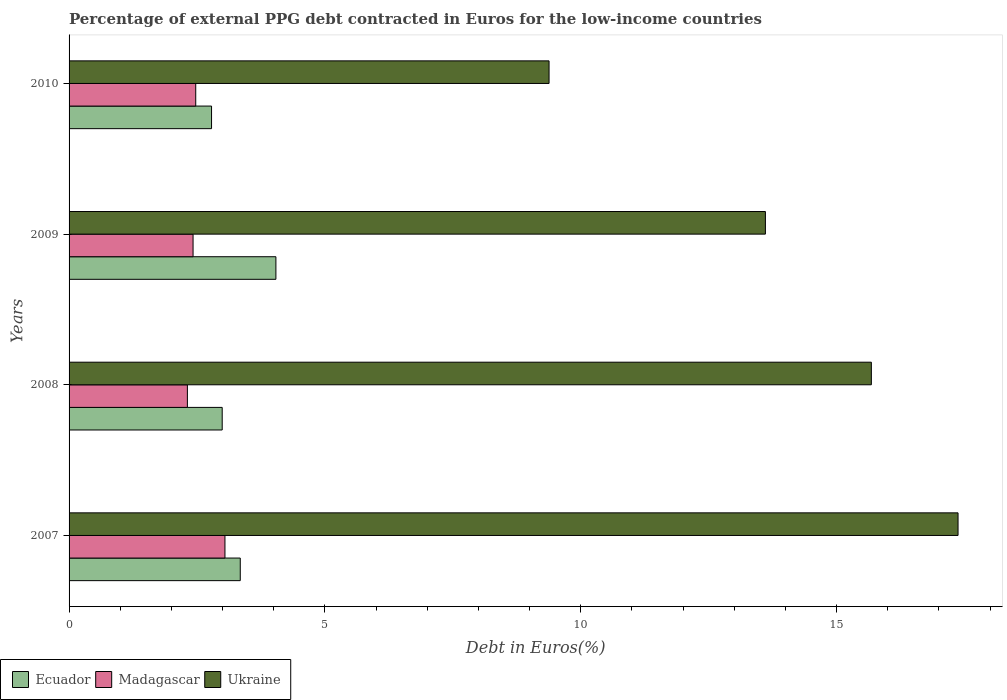Are the number of bars per tick equal to the number of legend labels?
Your answer should be very brief. Yes. How many bars are there on the 4th tick from the top?
Make the answer very short. 3. In how many cases, is the number of bars for a given year not equal to the number of legend labels?
Your response must be concise. 0. What is the percentage of external PPG debt contracted in Euros in Madagascar in 2009?
Offer a very short reply. 2.42. Across all years, what is the maximum percentage of external PPG debt contracted in Euros in Madagascar?
Make the answer very short. 3.05. Across all years, what is the minimum percentage of external PPG debt contracted in Euros in Madagascar?
Ensure brevity in your answer.  2.31. What is the total percentage of external PPG debt contracted in Euros in Ecuador in the graph?
Ensure brevity in your answer.  13.17. What is the difference between the percentage of external PPG debt contracted in Euros in Ukraine in 2008 and that in 2009?
Ensure brevity in your answer.  2.07. What is the difference between the percentage of external PPG debt contracted in Euros in Ecuador in 2010 and the percentage of external PPG debt contracted in Euros in Ukraine in 2007?
Your answer should be very brief. -14.59. What is the average percentage of external PPG debt contracted in Euros in Ukraine per year?
Your answer should be very brief. 14.01. In the year 2008, what is the difference between the percentage of external PPG debt contracted in Euros in Madagascar and percentage of external PPG debt contracted in Euros in Ukraine?
Offer a terse response. -13.37. In how many years, is the percentage of external PPG debt contracted in Euros in Madagascar greater than 1 %?
Your answer should be very brief. 4. What is the ratio of the percentage of external PPG debt contracted in Euros in Ukraine in 2007 to that in 2008?
Your answer should be compact. 1.11. Is the percentage of external PPG debt contracted in Euros in Ukraine in 2007 less than that in 2010?
Ensure brevity in your answer.  No. What is the difference between the highest and the second highest percentage of external PPG debt contracted in Euros in Madagascar?
Your answer should be compact. 0.57. What is the difference between the highest and the lowest percentage of external PPG debt contracted in Euros in Ecuador?
Provide a succinct answer. 1.26. In how many years, is the percentage of external PPG debt contracted in Euros in Madagascar greater than the average percentage of external PPG debt contracted in Euros in Madagascar taken over all years?
Make the answer very short. 1. Is the sum of the percentage of external PPG debt contracted in Euros in Ukraine in 2007 and 2010 greater than the maximum percentage of external PPG debt contracted in Euros in Madagascar across all years?
Ensure brevity in your answer.  Yes. What does the 3rd bar from the top in 2010 represents?
Offer a terse response. Ecuador. What does the 2nd bar from the bottom in 2008 represents?
Provide a succinct answer. Madagascar. Are all the bars in the graph horizontal?
Keep it short and to the point. Yes. What is the difference between two consecutive major ticks on the X-axis?
Provide a succinct answer. 5. Does the graph contain grids?
Your answer should be very brief. No. How many legend labels are there?
Provide a short and direct response. 3. How are the legend labels stacked?
Provide a succinct answer. Horizontal. What is the title of the graph?
Provide a short and direct response. Percentage of external PPG debt contracted in Euros for the low-income countries. Does "Tunisia" appear as one of the legend labels in the graph?
Give a very brief answer. No. What is the label or title of the X-axis?
Offer a terse response. Debt in Euros(%). What is the Debt in Euros(%) of Ecuador in 2007?
Your answer should be compact. 3.35. What is the Debt in Euros(%) of Madagascar in 2007?
Provide a succinct answer. 3.05. What is the Debt in Euros(%) of Ukraine in 2007?
Provide a succinct answer. 17.38. What is the Debt in Euros(%) of Ecuador in 2008?
Provide a short and direct response. 2.99. What is the Debt in Euros(%) in Madagascar in 2008?
Your response must be concise. 2.31. What is the Debt in Euros(%) in Ukraine in 2008?
Ensure brevity in your answer.  15.68. What is the Debt in Euros(%) in Ecuador in 2009?
Keep it short and to the point. 4.04. What is the Debt in Euros(%) in Madagascar in 2009?
Offer a terse response. 2.42. What is the Debt in Euros(%) in Ukraine in 2009?
Ensure brevity in your answer.  13.61. What is the Debt in Euros(%) of Ecuador in 2010?
Provide a succinct answer. 2.78. What is the Debt in Euros(%) in Madagascar in 2010?
Offer a very short reply. 2.48. What is the Debt in Euros(%) of Ukraine in 2010?
Your answer should be compact. 9.38. Across all years, what is the maximum Debt in Euros(%) in Ecuador?
Provide a succinct answer. 4.04. Across all years, what is the maximum Debt in Euros(%) in Madagascar?
Offer a very short reply. 3.05. Across all years, what is the maximum Debt in Euros(%) in Ukraine?
Offer a very short reply. 17.38. Across all years, what is the minimum Debt in Euros(%) of Ecuador?
Your answer should be very brief. 2.78. Across all years, what is the minimum Debt in Euros(%) of Madagascar?
Your response must be concise. 2.31. Across all years, what is the minimum Debt in Euros(%) in Ukraine?
Ensure brevity in your answer.  9.38. What is the total Debt in Euros(%) in Ecuador in the graph?
Your answer should be compact. 13.17. What is the total Debt in Euros(%) in Madagascar in the graph?
Your response must be concise. 10.26. What is the total Debt in Euros(%) in Ukraine in the graph?
Give a very brief answer. 56.05. What is the difference between the Debt in Euros(%) of Ecuador in 2007 and that in 2008?
Ensure brevity in your answer.  0.35. What is the difference between the Debt in Euros(%) of Madagascar in 2007 and that in 2008?
Your answer should be compact. 0.73. What is the difference between the Debt in Euros(%) of Ukraine in 2007 and that in 2008?
Offer a terse response. 1.69. What is the difference between the Debt in Euros(%) of Ecuador in 2007 and that in 2009?
Your answer should be very brief. -0.7. What is the difference between the Debt in Euros(%) in Madagascar in 2007 and that in 2009?
Keep it short and to the point. 0.62. What is the difference between the Debt in Euros(%) in Ukraine in 2007 and that in 2009?
Make the answer very short. 3.77. What is the difference between the Debt in Euros(%) in Ecuador in 2007 and that in 2010?
Your answer should be very brief. 0.56. What is the difference between the Debt in Euros(%) in Madagascar in 2007 and that in 2010?
Ensure brevity in your answer.  0.57. What is the difference between the Debt in Euros(%) of Ukraine in 2007 and that in 2010?
Provide a short and direct response. 7.99. What is the difference between the Debt in Euros(%) in Ecuador in 2008 and that in 2009?
Your answer should be very brief. -1.05. What is the difference between the Debt in Euros(%) of Madagascar in 2008 and that in 2009?
Provide a short and direct response. -0.11. What is the difference between the Debt in Euros(%) of Ukraine in 2008 and that in 2009?
Offer a terse response. 2.07. What is the difference between the Debt in Euros(%) of Ecuador in 2008 and that in 2010?
Keep it short and to the point. 0.21. What is the difference between the Debt in Euros(%) in Madagascar in 2008 and that in 2010?
Your answer should be compact. -0.16. What is the difference between the Debt in Euros(%) in Ukraine in 2008 and that in 2010?
Ensure brevity in your answer.  6.3. What is the difference between the Debt in Euros(%) in Ecuador in 2009 and that in 2010?
Offer a terse response. 1.26. What is the difference between the Debt in Euros(%) in Madagascar in 2009 and that in 2010?
Your answer should be compact. -0.05. What is the difference between the Debt in Euros(%) in Ukraine in 2009 and that in 2010?
Make the answer very short. 4.23. What is the difference between the Debt in Euros(%) in Ecuador in 2007 and the Debt in Euros(%) in Madagascar in 2008?
Offer a terse response. 1.03. What is the difference between the Debt in Euros(%) of Ecuador in 2007 and the Debt in Euros(%) of Ukraine in 2008?
Your response must be concise. -12.33. What is the difference between the Debt in Euros(%) of Madagascar in 2007 and the Debt in Euros(%) of Ukraine in 2008?
Offer a very short reply. -12.63. What is the difference between the Debt in Euros(%) in Ecuador in 2007 and the Debt in Euros(%) in Madagascar in 2009?
Your answer should be compact. 0.92. What is the difference between the Debt in Euros(%) in Ecuador in 2007 and the Debt in Euros(%) in Ukraine in 2009?
Ensure brevity in your answer.  -10.26. What is the difference between the Debt in Euros(%) of Madagascar in 2007 and the Debt in Euros(%) of Ukraine in 2009?
Offer a terse response. -10.56. What is the difference between the Debt in Euros(%) in Ecuador in 2007 and the Debt in Euros(%) in Madagascar in 2010?
Your answer should be very brief. 0.87. What is the difference between the Debt in Euros(%) in Ecuador in 2007 and the Debt in Euros(%) in Ukraine in 2010?
Your answer should be compact. -6.04. What is the difference between the Debt in Euros(%) of Madagascar in 2007 and the Debt in Euros(%) of Ukraine in 2010?
Your answer should be compact. -6.33. What is the difference between the Debt in Euros(%) of Ecuador in 2008 and the Debt in Euros(%) of Madagascar in 2009?
Ensure brevity in your answer.  0.57. What is the difference between the Debt in Euros(%) in Ecuador in 2008 and the Debt in Euros(%) in Ukraine in 2009?
Offer a terse response. -10.62. What is the difference between the Debt in Euros(%) in Madagascar in 2008 and the Debt in Euros(%) in Ukraine in 2009?
Ensure brevity in your answer.  -11.3. What is the difference between the Debt in Euros(%) of Ecuador in 2008 and the Debt in Euros(%) of Madagascar in 2010?
Your response must be concise. 0.52. What is the difference between the Debt in Euros(%) in Ecuador in 2008 and the Debt in Euros(%) in Ukraine in 2010?
Offer a very short reply. -6.39. What is the difference between the Debt in Euros(%) in Madagascar in 2008 and the Debt in Euros(%) in Ukraine in 2010?
Your response must be concise. -7.07. What is the difference between the Debt in Euros(%) of Ecuador in 2009 and the Debt in Euros(%) of Madagascar in 2010?
Your answer should be compact. 1.57. What is the difference between the Debt in Euros(%) of Ecuador in 2009 and the Debt in Euros(%) of Ukraine in 2010?
Your response must be concise. -5.34. What is the difference between the Debt in Euros(%) in Madagascar in 2009 and the Debt in Euros(%) in Ukraine in 2010?
Offer a very short reply. -6.96. What is the average Debt in Euros(%) in Ecuador per year?
Offer a very short reply. 3.29. What is the average Debt in Euros(%) in Madagascar per year?
Provide a succinct answer. 2.56. What is the average Debt in Euros(%) in Ukraine per year?
Provide a succinct answer. 14.01. In the year 2007, what is the difference between the Debt in Euros(%) in Ecuador and Debt in Euros(%) in Madagascar?
Your answer should be compact. 0.3. In the year 2007, what is the difference between the Debt in Euros(%) of Ecuador and Debt in Euros(%) of Ukraine?
Ensure brevity in your answer.  -14.03. In the year 2007, what is the difference between the Debt in Euros(%) in Madagascar and Debt in Euros(%) in Ukraine?
Provide a short and direct response. -14.33. In the year 2008, what is the difference between the Debt in Euros(%) in Ecuador and Debt in Euros(%) in Madagascar?
Provide a succinct answer. 0.68. In the year 2008, what is the difference between the Debt in Euros(%) of Ecuador and Debt in Euros(%) of Ukraine?
Keep it short and to the point. -12.69. In the year 2008, what is the difference between the Debt in Euros(%) of Madagascar and Debt in Euros(%) of Ukraine?
Give a very brief answer. -13.37. In the year 2009, what is the difference between the Debt in Euros(%) of Ecuador and Debt in Euros(%) of Madagascar?
Make the answer very short. 1.62. In the year 2009, what is the difference between the Debt in Euros(%) in Ecuador and Debt in Euros(%) in Ukraine?
Offer a terse response. -9.57. In the year 2009, what is the difference between the Debt in Euros(%) in Madagascar and Debt in Euros(%) in Ukraine?
Your answer should be compact. -11.19. In the year 2010, what is the difference between the Debt in Euros(%) of Ecuador and Debt in Euros(%) of Madagascar?
Your answer should be very brief. 0.31. In the year 2010, what is the difference between the Debt in Euros(%) in Ecuador and Debt in Euros(%) in Ukraine?
Provide a short and direct response. -6.6. In the year 2010, what is the difference between the Debt in Euros(%) in Madagascar and Debt in Euros(%) in Ukraine?
Ensure brevity in your answer.  -6.91. What is the ratio of the Debt in Euros(%) of Ecuador in 2007 to that in 2008?
Offer a terse response. 1.12. What is the ratio of the Debt in Euros(%) of Madagascar in 2007 to that in 2008?
Make the answer very short. 1.32. What is the ratio of the Debt in Euros(%) of Ukraine in 2007 to that in 2008?
Provide a short and direct response. 1.11. What is the ratio of the Debt in Euros(%) of Ecuador in 2007 to that in 2009?
Ensure brevity in your answer.  0.83. What is the ratio of the Debt in Euros(%) in Madagascar in 2007 to that in 2009?
Provide a succinct answer. 1.26. What is the ratio of the Debt in Euros(%) in Ukraine in 2007 to that in 2009?
Give a very brief answer. 1.28. What is the ratio of the Debt in Euros(%) in Ecuador in 2007 to that in 2010?
Give a very brief answer. 1.2. What is the ratio of the Debt in Euros(%) of Madagascar in 2007 to that in 2010?
Your answer should be compact. 1.23. What is the ratio of the Debt in Euros(%) in Ukraine in 2007 to that in 2010?
Provide a short and direct response. 1.85. What is the ratio of the Debt in Euros(%) of Ecuador in 2008 to that in 2009?
Offer a very short reply. 0.74. What is the ratio of the Debt in Euros(%) in Madagascar in 2008 to that in 2009?
Provide a succinct answer. 0.95. What is the ratio of the Debt in Euros(%) in Ukraine in 2008 to that in 2009?
Provide a short and direct response. 1.15. What is the ratio of the Debt in Euros(%) of Ecuador in 2008 to that in 2010?
Give a very brief answer. 1.07. What is the ratio of the Debt in Euros(%) of Madagascar in 2008 to that in 2010?
Provide a short and direct response. 0.93. What is the ratio of the Debt in Euros(%) in Ukraine in 2008 to that in 2010?
Offer a very short reply. 1.67. What is the ratio of the Debt in Euros(%) in Ecuador in 2009 to that in 2010?
Your response must be concise. 1.45. What is the ratio of the Debt in Euros(%) in Madagascar in 2009 to that in 2010?
Offer a very short reply. 0.98. What is the ratio of the Debt in Euros(%) in Ukraine in 2009 to that in 2010?
Offer a very short reply. 1.45. What is the difference between the highest and the second highest Debt in Euros(%) in Ecuador?
Keep it short and to the point. 0.7. What is the difference between the highest and the second highest Debt in Euros(%) of Madagascar?
Provide a succinct answer. 0.57. What is the difference between the highest and the second highest Debt in Euros(%) of Ukraine?
Your answer should be compact. 1.69. What is the difference between the highest and the lowest Debt in Euros(%) of Ecuador?
Ensure brevity in your answer.  1.26. What is the difference between the highest and the lowest Debt in Euros(%) of Madagascar?
Your response must be concise. 0.73. What is the difference between the highest and the lowest Debt in Euros(%) of Ukraine?
Offer a terse response. 7.99. 